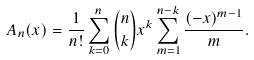<formula> <loc_0><loc_0><loc_500><loc_500>A _ { n } ( x ) = \frac { 1 } { n ! } \sum _ { k = 0 } ^ { n } \binom { n } { k } x ^ { k } \sum _ { m = 1 } ^ { n - k } \frac { ( - x ) ^ { m - 1 } } { m } .</formula> 